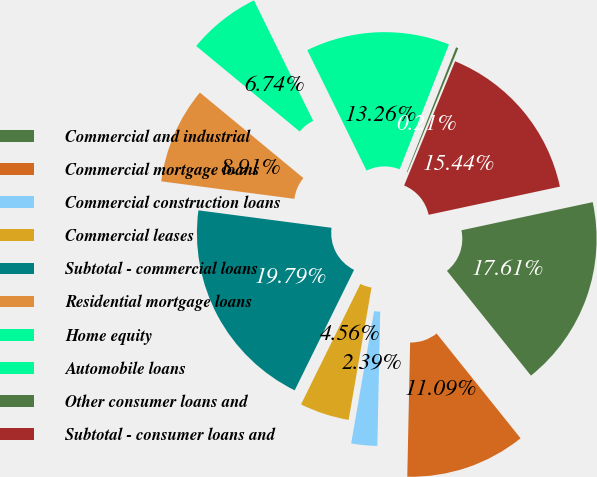<chart> <loc_0><loc_0><loc_500><loc_500><pie_chart><fcel>Commercial and industrial<fcel>Commercial mortgage loans<fcel>Commercial construction loans<fcel>Commercial leases<fcel>Subtotal - commercial loans<fcel>Residential mortgage loans<fcel>Home equity<fcel>Automobile loans<fcel>Other consumer loans and<fcel>Subtotal - consumer loans and<nl><fcel>17.61%<fcel>11.09%<fcel>2.39%<fcel>4.56%<fcel>19.79%<fcel>8.91%<fcel>6.74%<fcel>13.26%<fcel>0.21%<fcel>15.44%<nl></chart> 